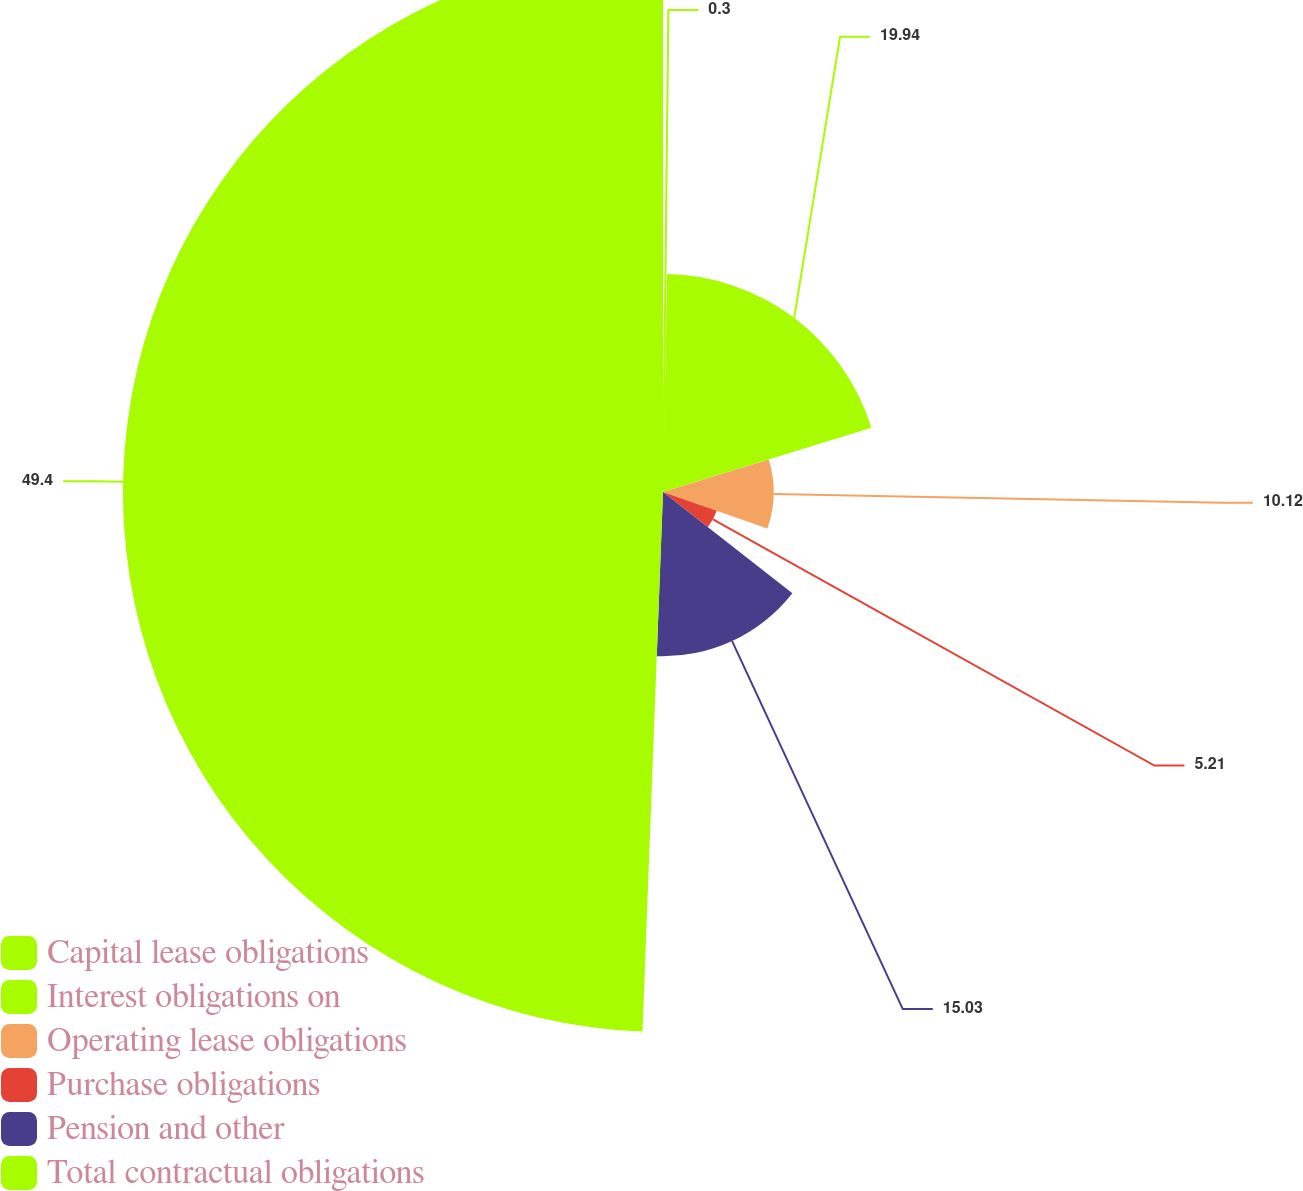Convert chart. <chart><loc_0><loc_0><loc_500><loc_500><pie_chart><fcel>Capital lease obligations<fcel>Interest obligations on<fcel>Operating lease obligations<fcel>Purchase obligations<fcel>Pension and other<fcel>Total contractual obligations<nl><fcel>0.3%<fcel>19.94%<fcel>10.12%<fcel>5.21%<fcel>15.03%<fcel>49.39%<nl></chart> 